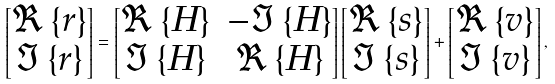Convert formula to latex. <formula><loc_0><loc_0><loc_500><loc_500>\begin{bmatrix} \Re \left \{ { r } \right \} \\ \Im \left \{ { r } \right \} \end{bmatrix} = \begin{bmatrix} \Re \left \{ { H } \right \} & - \Im \left \{ { H } \right \} \\ \Im \left \{ { H } \right \} & \Re \left \{ { H } \right \} \end{bmatrix} \begin{bmatrix} \Re \left \{ { s } \right \} \\ \Im \left \{ { s } \right \} \end{bmatrix} + \begin{bmatrix} \Re \left \{ { v } \right \} \\ \Im \left \{ { v } \right \} \end{bmatrix} ,</formula> 